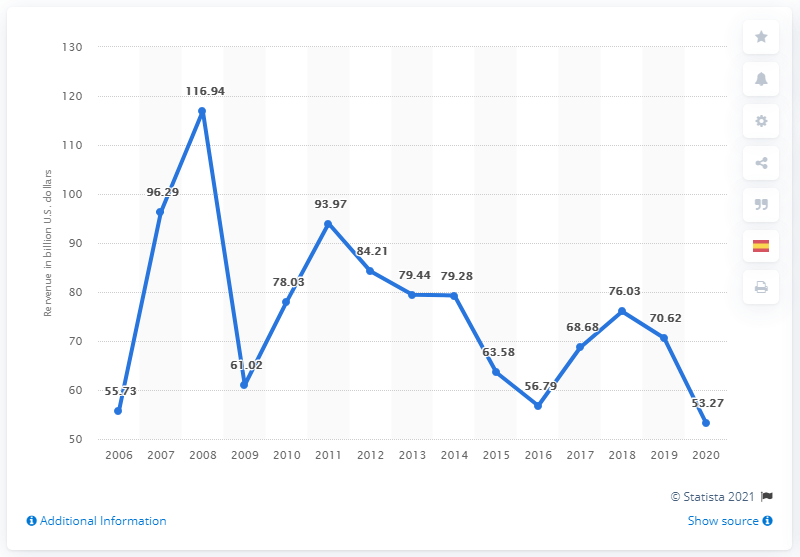Give some essential details in this illustration. In the year 2007, the revenue of ArcelorMittal was 96.29 billion U.S. dollars. In the year 2006, ArcelorMittal's last fiscal year, was the last fiscal year. ArcelorMittal's revenues in the year with the highest revenue between 2006 and 2020 were $63.67 billion, while the year with the lowest revenue was $24.13 billion. In the fiscal year of 2020, ArcelorMittal generated a revenue of 53.27 billion USD. 